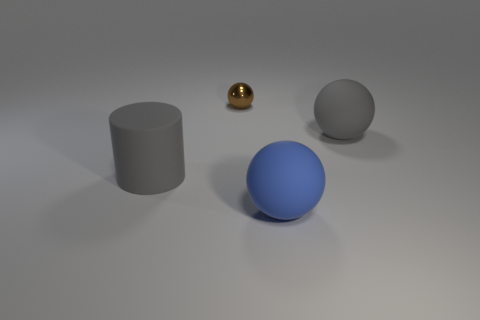Is there any other thing that is the same color as the big cylinder?
Ensure brevity in your answer.  Yes. There is a ball that is both to the left of the large gray matte ball and behind the blue matte thing; what material is it?
Provide a short and direct response. Metal. There is a gray matte object in front of the big gray matte ball; is its shape the same as the object that is behind the big gray sphere?
Your response must be concise. No. Is there any other thing that has the same material as the brown thing?
Make the answer very short. No. The gray rubber object that is in front of the big gray rubber thing that is behind the gray rubber thing that is to the left of the tiny metallic thing is what shape?
Provide a short and direct response. Cylinder. What number of other things are the same shape as the brown thing?
Your response must be concise. 2. There is a cylinder that is the same size as the blue object; what is its color?
Offer a very short reply. Gray. What number of cylinders are red metal things or blue things?
Your answer should be very brief. 0. How many large gray matte things are there?
Your response must be concise. 2. There is a brown thing; does it have the same shape as the large gray object right of the tiny object?
Your answer should be very brief. Yes. 